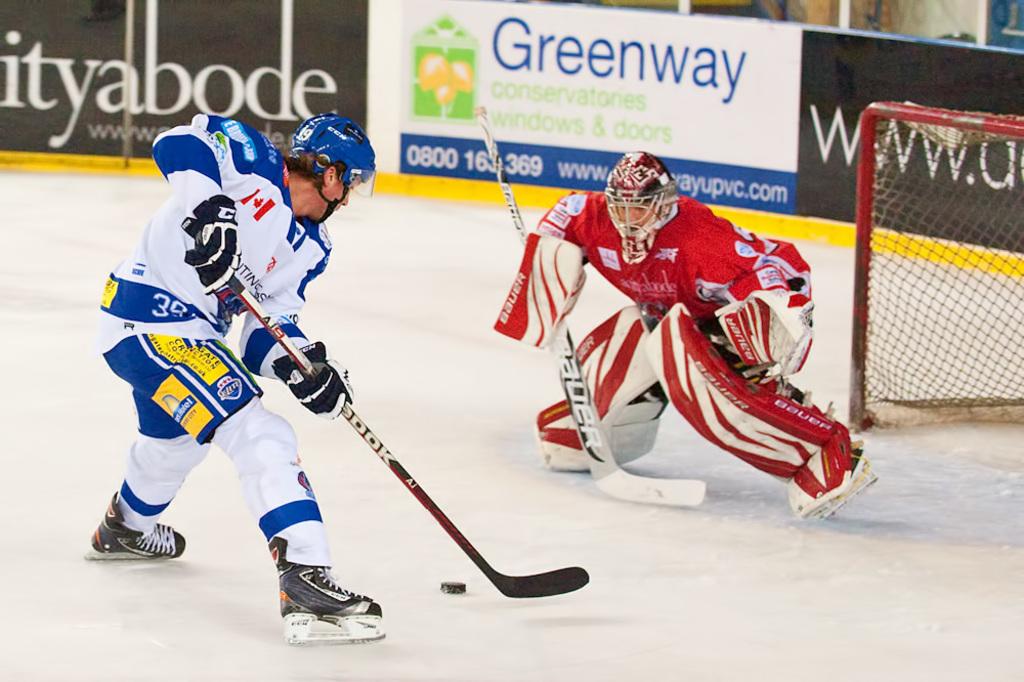What window and door company is advertising in the arena?
Offer a terse response. Greenway. What number is the player on the blue uniform?
Give a very brief answer. 39. 